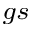Convert formula to latex. <formula><loc_0><loc_0><loc_500><loc_500>_ { g s }</formula> 